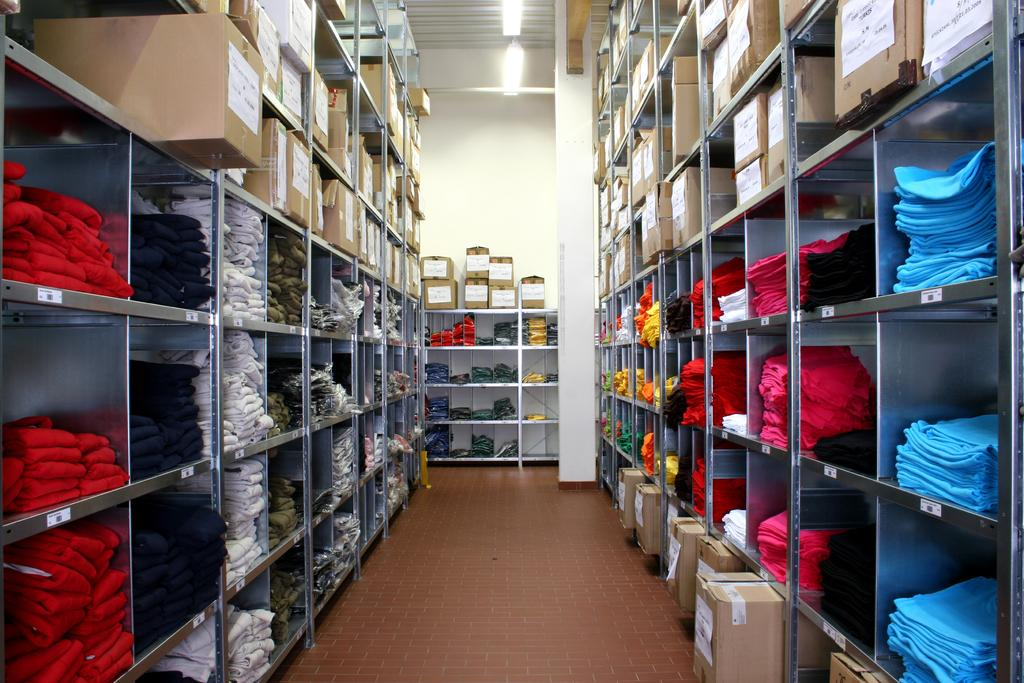What items can be found in the shelves in the image? There are clothes and cartons in the shelves in the image. What type of illumination is present in the image? There are lights at the top of the image. What type of oil is being used to lubricate the hobbies in the image? There is no oil or hobbies present in the image. Is there a veil covering any of the items in the shelves? There is no veil present in the image. 